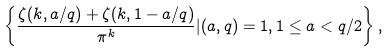<formula> <loc_0><loc_0><loc_500><loc_500>\left \{ \frac { \zeta ( k , a / q ) + \zeta ( k , 1 - a / q ) } { \pi ^ { k } } | ( a , q ) = 1 , 1 \leq a < q / 2 \right \} ,</formula> 